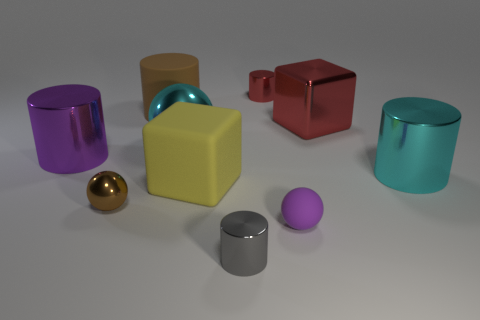Subtract all red cylinders. How many cylinders are left? 4 Subtract all big cyan metal cylinders. How many cylinders are left? 4 Subtract all yellow cylinders. Subtract all cyan cubes. How many cylinders are left? 5 Subtract all blocks. How many objects are left? 8 Subtract all big cyan spheres. Subtract all large brown things. How many objects are left? 8 Add 4 big cyan cylinders. How many big cyan cylinders are left? 5 Add 2 small purple rubber balls. How many small purple rubber balls exist? 3 Subtract 1 gray cylinders. How many objects are left? 9 